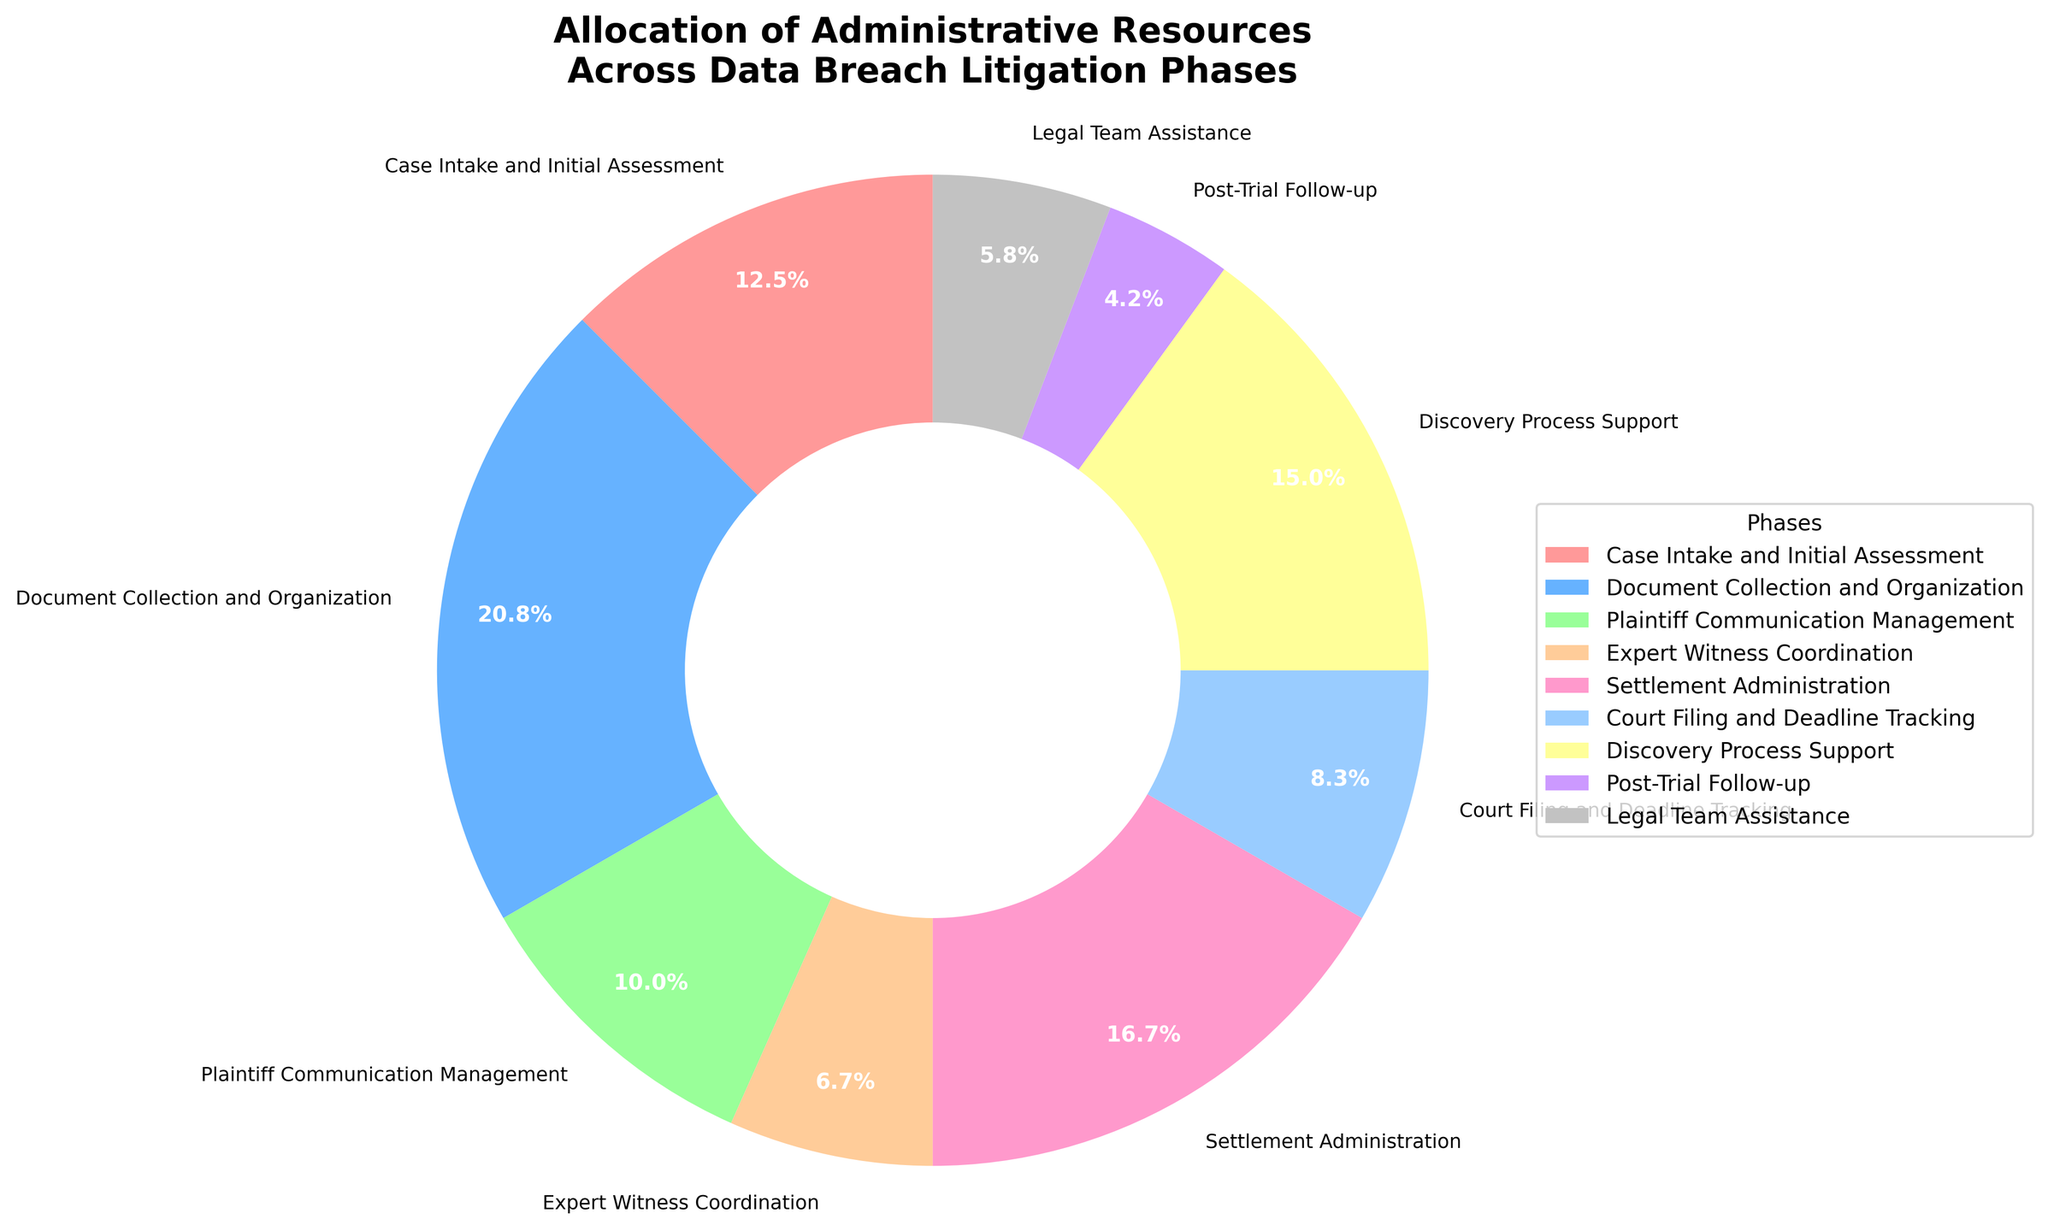what is the percentage difference between 'Document Collection and Organization' and 'Plaintiff Communication Management'? 'Document Collection and Organization' is 25% and 'Plaintiff Communication Management' is 12%. The percentage difference is calculated as: 25% - 12% = 13%
Answer: 13% Which phase has the smallest allocation of administrative resources? From the pie chart, 'Post-Trial Follow-up' has the smallest allocation at 5%.
Answer: Post-Trial Follow-up What is the combined percentage of 'Case Intake and Initial Assessment' and 'Court Filing and Deadline Tracking'? 'Case Intake and Initial Assessment' is 15%, and 'Court Filing and Deadline Tracking' is 10%. Their combined percentage is: 15% + 10% = 25%.
Answer: 25% Which phase uses more resources, 'Discovery Process Support' or 'Settlement Administration'? According to the chart, 'Discovery Process Support' is 18%, and 'Settlement Administration' is 20%. So, 'Settlement Administration' uses more resources.
Answer: Settlement Administration Among the phases, which one has the highest allocation of administrative resources? The pie chart indicates that 'Document Collection and Organization' has the highest allocation at 25%.
Answer: Document Collection and Organization What are the top three phases in terms of resource allocation? By examining the percentages, the top three phases are 'Document Collection and Organization' (25%), 'Settlement Administration' (20%), and 'Discovery Process Support' (18%).
Answer: Document Collection and Organization, Settlement Administration, Discovery Process Support How does the allocation for 'Legal Team Assistance' compare to 'Expert Witness Coordination'? 'Legal Team Assistance' is 7%, while 'Expert Witness Coordination' is 8%, so 'Expert Witness Coordination' has a slightly higher allocation.
Answer: Expert Witness Coordination What is the percentage sum of the three smallest phases? The three smallest phases are 'Post-Trial Follow-up' (5%), 'Legal Team Assistance' (7%), and 'Expert Witness Coordination' (8%). Their sum is: 5% + 7% + 8% = 20%.
Answer: 20% If phases with less than 10% resource allocation are considered minor, list them. From the chart, the phases with less than 10% resource allocation are 'Expert Witness Coordination' (8%), 'Court Filing and Deadline Tracking' (10%), 'Post-Trial Follow-up' (5%), and 'Legal Team Assistance' (7%).
Answer: Expert Witness Coordination, Post-Trial Follow-up, Legal Team Assistance 